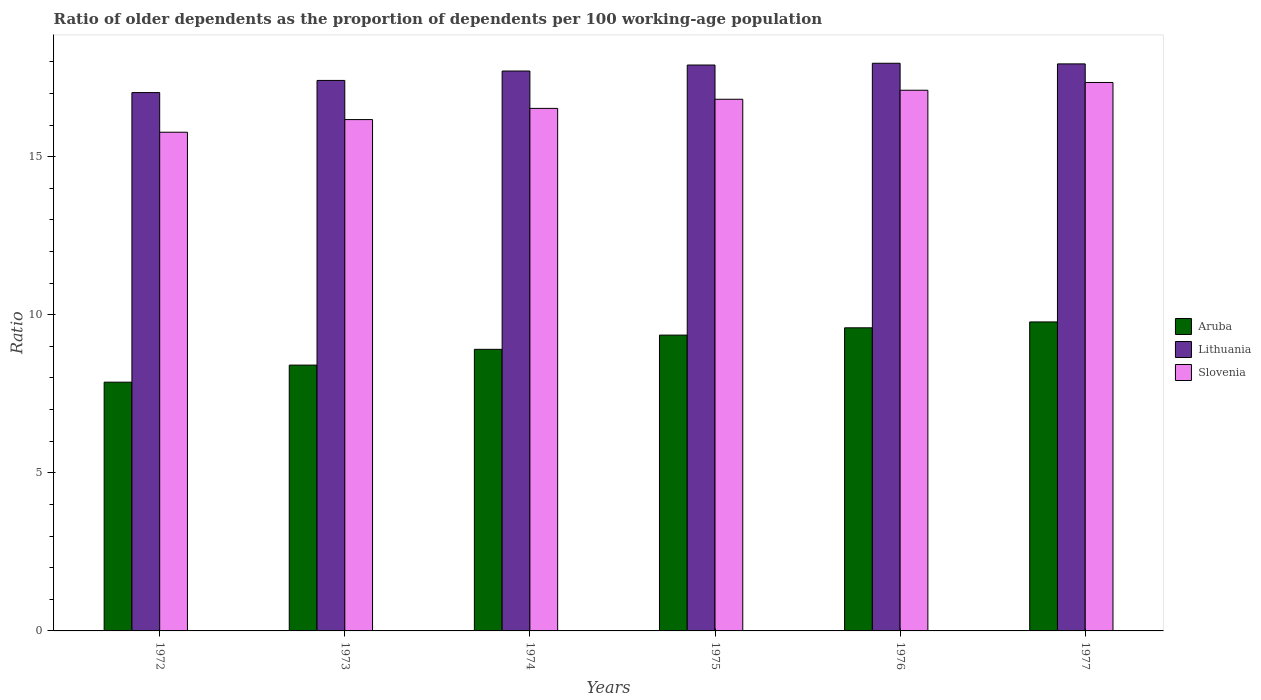How many different coloured bars are there?
Make the answer very short. 3. How many bars are there on the 4th tick from the left?
Provide a succinct answer. 3. In how many cases, is the number of bars for a given year not equal to the number of legend labels?
Offer a terse response. 0. What is the age dependency ratio(old) in Lithuania in 1974?
Provide a short and direct response. 17.71. Across all years, what is the maximum age dependency ratio(old) in Slovenia?
Offer a terse response. 17.35. Across all years, what is the minimum age dependency ratio(old) in Slovenia?
Your answer should be very brief. 15.77. In which year was the age dependency ratio(old) in Lithuania minimum?
Provide a succinct answer. 1972. What is the total age dependency ratio(old) in Slovenia in the graph?
Your answer should be very brief. 99.74. What is the difference between the age dependency ratio(old) in Lithuania in 1973 and that in 1974?
Your response must be concise. -0.3. What is the difference between the age dependency ratio(old) in Lithuania in 1973 and the age dependency ratio(old) in Slovenia in 1976?
Provide a succinct answer. 0.31. What is the average age dependency ratio(old) in Aruba per year?
Provide a short and direct response. 8.98. In the year 1973, what is the difference between the age dependency ratio(old) in Aruba and age dependency ratio(old) in Slovenia?
Your answer should be very brief. -7.77. What is the ratio of the age dependency ratio(old) in Slovenia in 1974 to that in 1977?
Ensure brevity in your answer.  0.95. Is the difference between the age dependency ratio(old) in Aruba in 1972 and 1973 greater than the difference between the age dependency ratio(old) in Slovenia in 1972 and 1973?
Your response must be concise. No. What is the difference between the highest and the second highest age dependency ratio(old) in Slovenia?
Ensure brevity in your answer.  0.25. What is the difference between the highest and the lowest age dependency ratio(old) in Slovenia?
Ensure brevity in your answer.  1.57. In how many years, is the age dependency ratio(old) in Lithuania greater than the average age dependency ratio(old) in Lithuania taken over all years?
Offer a very short reply. 4. What does the 1st bar from the left in 1972 represents?
Provide a succinct answer. Aruba. What does the 2nd bar from the right in 1977 represents?
Ensure brevity in your answer.  Lithuania. Is it the case that in every year, the sum of the age dependency ratio(old) in Slovenia and age dependency ratio(old) in Lithuania is greater than the age dependency ratio(old) in Aruba?
Offer a terse response. Yes. How many bars are there?
Provide a succinct answer. 18. Are the values on the major ticks of Y-axis written in scientific E-notation?
Your answer should be compact. No. Where does the legend appear in the graph?
Ensure brevity in your answer.  Center right. How are the legend labels stacked?
Ensure brevity in your answer.  Vertical. What is the title of the graph?
Ensure brevity in your answer.  Ratio of older dependents as the proportion of dependents per 100 working-age population. Does "Costa Rica" appear as one of the legend labels in the graph?
Provide a short and direct response. No. What is the label or title of the X-axis?
Give a very brief answer. Years. What is the label or title of the Y-axis?
Your answer should be compact. Ratio. What is the Ratio of Aruba in 1972?
Give a very brief answer. 7.87. What is the Ratio in Lithuania in 1972?
Your response must be concise. 17.03. What is the Ratio in Slovenia in 1972?
Your response must be concise. 15.77. What is the Ratio in Aruba in 1973?
Give a very brief answer. 8.41. What is the Ratio of Lithuania in 1973?
Offer a very short reply. 17.41. What is the Ratio of Slovenia in 1973?
Keep it short and to the point. 16.17. What is the Ratio in Aruba in 1974?
Make the answer very short. 8.91. What is the Ratio of Lithuania in 1974?
Make the answer very short. 17.71. What is the Ratio of Slovenia in 1974?
Keep it short and to the point. 16.53. What is the Ratio in Aruba in 1975?
Provide a succinct answer. 9.36. What is the Ratio of Lithuania in 1975?
Offer a terse response. 17.9. What is the Ratio in Slovenia in 1975?
Keep it short and to the point. 16.82. What is the Ratio in Aruba in 1976?
Offer a very short reply. 9.59. What is the Ratio in Lithuania in 1976?
Ensure brevity in your answer.  17.96. What is the Ratio in Slovenia in 1976?
Your response must be concise. 17.1. What is the Ratio of Aruba in 1977?
Keep it short and to the point. 9.77. What is the Ratio of Lithuania in 1977?
Provide a succinct answer. 17.94. What is the Ratio in Slovenia in 1977?
Offer a very short reply. 17.35. Across all years, what is the maximum Ratio in Aruba?
Provide a short and direct response. 9.77. Across all years, what is the maximum Ratio of Lithuania?
Make the answer very short. 17.96. Across all years, what is the maximum Ratio in Slovenia?
Your answer should be very brief. 17.35. Across all years, what is the minimum Ratio of Aruba?
Your answer should be compact. 7.87. Across all years, what is the minimum Ratio of Lithuania?
Give a very brief answer. 17.03. Across all years, what is the minimum Ratio of Slovenia?
Give a very brief answer. 15.77. What is the total Ratio in Aruba in the graph?
Offer a very short reply. 53.9. What is the total Ratio in Lithuania in the graph?
Give a very brief answer. 105.94. What is the total Ratio in Slovenia in the graph?
Your response must be concise. 99.74. What is the difference between the Ratio of Aruba in 1972 and that in 1973?
Provide a succinct answer. -0.54. What is the difference between the Ratio of Lithuania in 1972 and that in 1973?
Make the answer very short. -0.38. What is the difference between the Ratio of Slovenia in 1972 and that in 1973?
Keep it short and to the point. -0.4. What is the difference between the Ratio of Aruba in 1972 and that in 1974?
Offer a terse response. -1.04. What is the difference between the Ratio in Lithuania in 1972 and that in 1974?
Keep it short and to the point. -0.68. What is the difference between the Ratio of Slovenia in 1972 and that in 1974?
Give a very brief answer. -0.75. What is the difference between the Ratio in Aruba in 1972 and that in 1975?
Ensure brevity in your answer.  -1.49. What is the difference between the Ratio of Lithuania in 1972 and that in 1975?
Offer a terse response. -0.87. What is the difference between the Ratio of Slovenia in 1972 and that in 1975?
Your answer should be compact. -1.04. What is the difference between the Ratio in Aruba in 1972 and that in 1976?
Provide a succinct answer. -1.72. What is the difference between the Ratio in Lithuania in 1972 and that in 1976?
Offer a terse response. -0.93. What is the difference between the Ratio in Slovenia in 1972 and that in 1976?
Provide a succinct answer. -1.33. What is the difference between the Ratio of Aruba in 1972 and that in 1977?
Ensure brevity in your answer.  -1.91. What is the difference between the Ratio of Lithuania in 1972 and that in 1977?
Your answer should be compact. -0.91. What is the difference between the Ratio in Slovenia in 1972 and that in 1977?
Your answer should be very brief. -1.57. What is the difference between the Ratio of Aruba in 1973 and that in 1974?
Offer a very short reply. -0.5. What is the difference between the Ratio in Lithuania in 1973 and that in 1974?
Ensure brevity in your answer.  -0.3. What is the difference between the Ratio of Slovenia in 1973 and that in 1974?
Give a very brief answer. -0.35. What is the difference between the Ratio in Aruba in 1973 and that in 1975?
Make the answer very short. -0.95. What is the difference between the Ratio of Lithuania in 1973 and that in 1975?
Provide a short and direct response. -0.49. What is the difference between the Ratio of Slovenia in 1973 and that in 1975?
Offer a very short reply. -0.64. What is the difference between the Ratio in Aruba in 1973 and that in 1976?
Your response must be concise. -1.18. What is the difference between the Ratio in Lithuania in 1973 and that in 1976?
Your answer should be compact. -0.54. What is the difference between the Ratio of Slovenia in 1973 and that in 1976?
Your response must be concise. -0.93. What is the difference between the Ratio in Aruba in 1973 and that in 1977?
Ensure brevity in your answer.  -1.37. What is the difference between the Ratio of Lithuania in 1973 and that in 1977?
Make the answer very short. -0.52. What is the difference between the Ratio in Slovenia in 1973 and that in 1977?
Make the answer very short. -1.17. What is the difference between the Ratio of Aruba in 1974 and that in 1975?
Offer a terse response. -0.45. What is the difference between the Ratio in Lithuania in 1974 and that in 1975?
Ensure brevity in your answer.  -0.19. What is the difference between the Ratio in Slovenia in 1974 and that in 1975?
Your answer should be very brief. -0.29. What is the difference between the Ratio in Aruba in 1974 and that in 1976?
Make the answer very short. -0.68. What is the difference between the Ratio of Lithuania in 1974 and that in 1976?
Provide a succinct answer. -0.25. What is the difference between the Ratio in Slovenia in 1974 and that in 1976?
Provide a succinct answer. -0.57. What is the difference between the Ratio of Aruba in 1974 and that in 1977?
Provide a succinct answer. -0.87. What is the difference between the Ratio of Lithuania in 1974 and that in 1977?
Your response must be concise. -0.23. What is the difference between the Ratio of Slovenia in 1974 and that in 1977?
Your answer should be compact. -0.82. What is the difference between the Ratio in Aruba in 1975 and that in 1976?
Offer a very short reply. -0.23. What is the difference between the Ratio in Lithuania in 1975 and that in 1976?
Your answer should be very brief. -0.06. What is the difference between the Ratio of Slovenia in 1975 and that in 1976?
Provide a short and direct response. -0.29. What is the difference between the Ratio in Aruba in 1975 and that in 1977?
Provide a succinct answer. -0.42. What is the difference between the Ratio of Lithuania in 1975 and that in 1977?
Your response must be concise. -0.04. What is the difference between the Ratio of Slovenia in 1975 and that in 1977?
Provide a succinct answer. -0.53. What is the difference between the Ratio of Aruba in 1976 and that in 1977?
Make the answer very short. -0.19. What is the difference between the Ratio in Lithuania in 1976 and that in 1977?
Give a very brief answer. 0.02. What is the difference between the Ratio in Slovenia in 1976 and that in 1977?
Make the answer very short. -0.25. What is the difference between the Ratio of Aruba in 1972 and the Ratio of Lithuania in 1973?
Offer a very short reply. -9.54. What is the difference between the Ratio of Aruba in 1972 and the Ratio of Slovenia in 1973?
Keep it short and to the point. -8.31. What is the difference between the Ratio in Lithuania in 1972 and the Ratio in Slovenia in 1973?
Your answer should be compact. 0.85. What is the difference between the Ratio of Aruba in 1972 and the Ratio of Lithuania in 1974?
Your answer should be compact. -9.84. What is the difference between the Ratio in Aruba in 1972 and the Ratio in Slovenia in 1974?
Your answer should be very brief. -8.66. What is the difference between the Ratio in Lithuania in 1972 and the Ratio in Slovenia in 1974?
Give a very brief answer. 0.5. What is the difference between the Ratio of Aruba in 1972 and the Ratio of Lithuania in 1975?
Provide a short and direct response. -10.03. What is the difference between the Ratio of Aruba in 1972 and the Ratio of Slovenia in 1975?
Your answer should be very brief. -8.95. What is the difference between the Ratio in Lithuania in 1972 and the Ratio in Slovenia in 1975?
Your answer should be compact. 0.21. What is the difference between the Ratio in Aruba in 1972 and the Ratio in Lithuania in 1976?
Keep it short and to the point. -10.09. What is the difference between the Ratio of Aruba in 1972 and the Ratio of Slovenia in 1976?
Give a very brief answer. -9.23. What is the difference between the Ratio of Lithuania in 1972 and the Ratio of Slovenia in 1976?
Give a very brief answer. -0.07. What is the difference between the Ratio of Aruba in 1972 and the Ratio of Lithuania in 1977?
Provide a succinct answer. -10.07. What is the difference between the Ratio in Aruba in 1972 and the Ratio in Slovenia in 1977?
Make the answer very short. -9.48. What is the difference between the Ratio in Lithuania in 1972 and the Ratio in Slovenia in 1977?
Offer a terse response. -0.32. What is the difference between the Ratio in Aruba in 1973 and the Ratio in Lithuania in 1974?
Give a very brief answer. -9.3. What is the difference between the Ratio of Aruba in 1973 and the Ratio of Slovenia in 1974?
Offer a terse response. -8.12. What is the difference between the Ratio in Lithuania in 1973 and the Ratio in Slovenia in 1974?
Offer a terse response. 0.88. What is the difference between the Ratio in Aruba in 1973 and the Ratio in Lithuania in 1975?
Give a very brief answer. -9.49. What is the difference between the Ratio of Aruba in 1973 and the Ratio of Slovenia in 1975?
Give a very brief answer. -8.41. What is the difference between the Ratio in Lithuania in 1973 and the Ratio in Slovenia in 1975?
Make the answer very short. 0.6. What is the difference between the Ratio of Aruba in 1973 and the Ratio of Lithuania in 1976?
Offer a terse response. -9.55. What is the difference between the Ratio of Aruba in 1973 and the Ratio of Slovenia in 1976?
Provide a short and direct response. -8.69. What is the difference between the Ratio of Lithuania in 1973 and the Ratio of Slovenia in 1976?
Ensure brevity in your answer.  0.31. What is the difference between the Ratio of Aruba in 1973 and the Ratio of Lithuania in 1977?
Provide a short and direct response. -9.53. What is the difference between the Ratio in Aruba in 1973 and the Ratio in Slovenia in 1977?
Give a very brief answer. -8.94. What is the difference between the Ratio in Lithuania in 1973 and the Ratio in Slovenia in 1977?
Provide a succinct answer. 0.06. What is the difference between the Ratio of Aruba in 1974 and the Ratio of Lithuania in 1975?
Provide a succinct answer. -8.99. What is the difference between the Ratio in Aruba in 1974 and the Ratio in Slovenia in 1975?
Keep it short and to the point. -7.91. What is the difference between the Ratio of Lithuania in 1974 and the Ratio of Slovenia in 1975?
Give a very brief answer. 0.89. What is the difference between the Ratio in Aruba in 1974 and the Ratio in Lithuania in 1976?
Give a very brief answer. -9.05. What is the difference between the Ratio in Aruba in 1974 and the Ratio in Slovenia in 1976?
Make the answer very short. -8.2. What is the difference between the Ratio in Lithuania in 1974 and the Ratio in Slovenia in 1976?
Offer a very short reply. 0.61. What is the difference between the Ratio in Aruba in 1974 and the Ratio in Lithuania in 1977?
Make the answer very short. -9.03. What is the difference between the Ratio of Aruba in 1974 and the Ratio of Slovenia in 1977?
Make the answer very short. -8.44. What is the difference between the Ratio of Lithuania in 1974 and the Ratio of Slovenia in 1977?
Your answer should be compact. 0.36. What is the difference between the Ratio in Aruba in 1975 and the Ratio in Lithuania in 1976?
Provide a succinct answer. -8.6. What is the difference between the Ratio in Aruba in 1975 and the Ratio in Slovenia in 1976?
Your response must be concise. -7.74. What is the difference between the Ratio of Lithuania in 1975 and the Ratio of Slovenia in 1976?
Keep it short and to the point. 0.8. What is the difference between the Ratio of Aruba in 1975 and the Ratio of Lithuania in 1977?
Your answer should be compact. -8.58. What is the difference between the Ratio of Aruba in 1975 and the Ratio of Slovenia in 1977?
Give a very brief answer. -7.99. What is the difference between the Ratio of Lithuania in 1975 and the Ratio of Slovenia in 1977?
Ensure brevity in your answer.  0.55. What is the difference between the Ratio of Aruba in 1976 and the Ratio of Lithuania in 1977?
Provide a succinct answer. -8.35. What is the difference between the Ratio in Aruba in 1976 and the Ratio in Slovenia in 1977?
Your answer should be compact. -7.76. What is the difference between the Ratio in Lithuania in 1976 and the Ratio in Slovenia in 1977?
Your answer should be compact. 0.61. What is the average Ratio of Aruba per year?
Your answer should be very brief. 8.98. What is the average Ratio of Lithuania per year?
Offer a terse response. 17.66. What is the average Ratio in Slovenia per year?
Offer a terse response. 16.62. In the year 1972, what is the difference between the Ratio in Aruba and Ratio in Lithuania?
Ensure brevity in your answer.  -9.16. In the year 1972, what is the difference between the Ratio in Aruba and Ratio in Slovenia?
Provide a short and direct response. -7.91. In the year 1972, what is the difference between the Ratio in Lithuania and Ratio in Slovenia?
Your answer should be very brief. 1.25. In the year 1973, what is the difference between the Ratio in Aruba and Ratio in Lithuania?
Make the answer very short. -9. In the year 1973, what is the difference between the Ratio of Aruba and Ratio of Slovenia?
Your answer should be compact. -7.77. In the year 1973, what is the difference between the Ratio of Lithuania and Ratio of Slovenia?
Make the answer very short. 1.24. In the year 1974, what is the difference between the Ratio in Aruba and Ratio in Lithuania?
Give a very brief answer. -8.8. In the year 1974, what is the difference between the Ratio of Aruba and Ratio of Slovenia?
Provide a short and direct response. -7.62. In the year 1974, what is the difference between the Ratio of Lithuania and Ratio of Slovenia?
Your response must be concise. 1.18. In the year 1975, what is the difference between the Ratio of Aruba and Ratio of Lithuania?
Offer a terse response. -8.54. In the year 1975, what is the difference between the Ratio in Aruba and Ratio in Slovenia?
Keep it short and to the point. -7.46. In the year 1975, what is the difference between the Ratio in Lithuania and Ratio in Slovenia?
Provide a succinct answer. 1.08. In the year 1976, what is the difference between the Ratio of Aruba and Ratio of Lithuania?
Your answer should be compact. -8.37. In the year 1976, what is the difference between the Ratio of Aruba and Ratio of Slovenia?
Give a very brief answer. -7.51. In the year 1976, what is the difference between the Ratio of Lithuania and Ratio of Slovenia?
Offer a very short reply. 0.85. In the year 1977, what is the difference between the Ratio of Aruba and Ratio of Lithuania?
Provide a succinct answer. -8.16. In the year 1977, what is the difference between the Ratio in Aruba and Ratio in Slovenia?
Keep it short and to the point. -7.57. In the year 1977, what is the difference between the Ratio in Lithuania and Ratio in Slovenia?
Make the answer very short. 0.59. What is the ratio of the Ratio in Aruba in 1972 to that in 1973?
Provide a short and direct response. 0.94. What is the ratio of the Ratio in Lithuania in 1972 to that in 1973?
Provide a short and direct response. 0.98. What is the ratio of the Ratio in Slovenia in 1972 to that in 1973?
Offer a terse response. 0.98. What is the ratio of the Ratio in Aruba in 1972 to that in 1974?
Ensure brevity in your answer.  0.88. What is the ratio of the Ratio in Lithuania in 1972 to that in 1974?
Offer a terse response. 0.96. What is the ratio of the Ratio in Slovenia in 1972 to that in 1974?
Offer a terse response. 0.95. What is the ratio of the Ratio of Aruba in 1972 to that in 1975?
Provide a short and direct response. 0.84. What is the ratio of the Ratio in Lithuania in 1972 to that in 1975?
Your response must be concise. 0.95. What is the ratio of the Ratio of Slovenia in 1972 to that in 1975?
Your response must be concise. 0.94. What is the ratio of the Ratio of Aruba in 1972 to that in 1976?
Provide a succinct answer. 0.82. What is the ratio of the Ratio of Lithuania in 1972 to that in 1976?
Offer a terse response. 0.95. What is the ratio of the Ratio in Slovenia in 1972 to that in 1976?
Your response must be concise. 0.92. What is the ratio of the Ratio of Aruba in 1972 to that in 1977?
Make the answer very short. 0.81. What is the ratio of the Ratio of Lithuania in 1972 to that in 1977?
Keep it short and to the point. 0.95. What is the ratio of the Ratio of Slovenia in 1972 to that in 1977?
Give a very brief answer. 0.91. What is the ratio of the Ratio of Aruba in 1973 to that in 1974?
Offer a terse response. 0.94. What is the ratio of the Ratio in Lithuania in 1973 to that in 1974?
Keep it short and to the point. 0.98. What is the ratio of the Ratio in Slovenia in 1973 to that in 1974?
Keep it short and to the point. 0.98. What is the ratio of the Ratio of Aruba in 1973 to that in 1975?
Ensure brevity in your answer.  0.9. What is the ratio of the Ratio of Lithuania in 1973 to that in 1975?
Your answer should be compact. 0.97. What is the ratio of the Ratio of Slovenia in 1973 to that in 1975?
Offer a terse response. 0.96. What is the ratio of the Ratio of Aruba in 1973 to that in 1976?
Your response must be concise. 0.88. What is the ratio of the Ratio in Lithuania in 1973 to that in 1976?
Offer a very short reply. 0.97. What is the ratio of the Ratio of Slovenia in 1973 to that in 1976?
Offer a very short reply. 0.95. What is the ratio of the Ratio in Aruba in 1973 to that in 1977?
Give a very brief answer. 0.86. What is the ratio of the Ratio in Lithuania in 1973 to that in 1977?
Provide a succinct answer. 0.97. What is the ratio of the Ratio of Slovenia in 1973 to that in 1977?
Provide a short and direct response. 0.93. What is the ratio of the Ratio of Aruba in 1974 to that in 1975?
Your answer should be compact. 0.95. What is the ratio of the Ratio in Slovenia in 1974 to that in 1975?
Your answer should be compact. 0.98. What is the ratio of the Ratio of Aruba in 1974 to that in 1976?
Give a very brief answer. 0.93. What is the ratio of the Ratio in Lithuania in 1974 to that in 1976?
Provide a short and direct response. 0.99. What is the ratio of the Ratio in Slovenia in 1974 to that in 1976?
Ensure brevity in your answer.  0.97. What is the ratio of the Ratio in Aruba in 1974 to that in 1977?
Ensure brevity in your answer.  0.91. What is the ratio of the Ratio of Lithuania in 1974 to that in 1977?
Provide a succinct answer. 0.99. What is the ratio of the Ratio of Slovenia in 1974 to that in 1977?
Give a very brief answer. 0.95. What is the ratio of the Ratio in Aruba in 1975 to that in 1976?
Provide a succinct answer. 0.98. What is the ratio of the Ratio in Lithuania in 1975 to that in 1976?
Your response must be concise. 1. What is the ratio of the Ratio of Slovenia in 1975 to that in 1976?
Your answer should be compact. 0.98. What is the ratio of the Ratio of Aruba in 1975 to that in 1977?
Your response must be concise. 0.96. What is the ratio of the Ratio of Slovenia in 1975 to that in 1977?
Make the answer very short. 0.97. What is the ratio of the Ratio in Aruba in 1976 to that in 1977?
Provide a succinct answer. 0.98. What is the ratio of the Ratio of Slovenia in 1976 to that in 1977?
Make the answer very short. 0.99. What is the difference between the highest and the second highest Ratio of Aruba?
Give a very brief answer. 0.19. What is the difference between the highest and the second highest Ratio of Lithuania?
Your response must be concise. 0.02. What is the difference between the highest and the second highest Ratio in Slovenia?
Keep it short and to the point. 0.25. What is the difference between the highest and the lowest Ratio in Aruba?
Your answer should be compact. 1.91. What is the difference between the highest and the lowest Ratio in Lithuania?
Provide a succinct answer. 0.93. What is the difference between the highest and the lowest Ratio of Slovenia?
Provide a short and direct response. 1.57. 